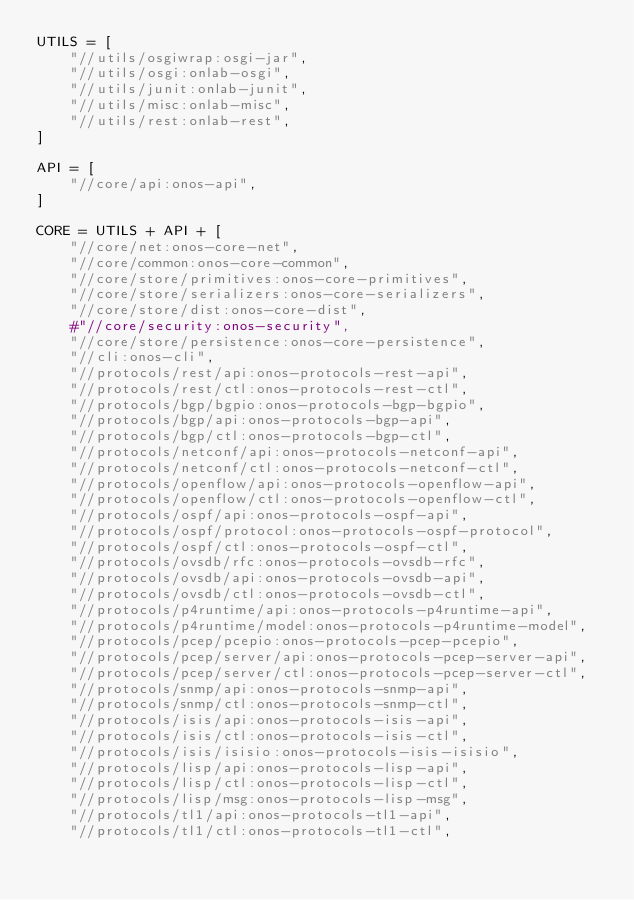Convert code to text. <code><loc_0><loc_0><loc_500><loc_500><_Python_>UTILS = [
    "//utils/osgiwrap:osgi-jar",
    "//utils/osgi:onlab-osgi",
    "//utils/junit:onlab-junit",
    "//utils/misc:onlab-misc",
    "//utils/rest:onlab-rest",
]

API = [
    "//core/api:onos-api",
]

CORE = UTILS + API + [
    "//core/net:onos-core-net",
    "//core/common:onos-core-common",
    "//core/store/primitives:onos-core-primitives",
    "//core/store/serializers:onos-core-serializers",
    "//core/store/dist:onos-core-dist",
    #"//core/security:onos-security",
    "//core/store/persistence:onos-core-persistence",
    "//cli:onos-cli",
    "//protocols/rest/api:onos-protocols-rest-api",
    "//protocols/rest/ctl:onos-protocols-rest-ctl",
    "//protocols/bgp/bgpio:onos-protocols-bgp-bgpio",
    "//protocols/bgp/api:onos-protocols-bgp-api",
    "//protocols/bgp/ctl:onos-protocols-bgp-ctl",
    "//protocols/netconf/api:onos-protocols-netconf-api",
    "//protocols/netconf/ctl:onos-protocols-netconf-ctl",
    "//protocols/openflow/api:onos-protocols-openflow-api",
    "//protocols/openflow/ctl:onos-protocols-openflow-ctl",
    "//protocols/ospf/api:onos-protocols-ospf-api",
    "//protocols/ospf/protocol:onos-protocols-ospf-protocol",
    "//protocols/ospf/ctl:onos-protocols-ospf-ctl",
    "//protocols/ovsdb/rfc:onos-protocols-ovsdb-rfc",
    "//protocols/ovsdb/api:onos-protocols-ovsdb-api",
    "//protocols/ovsdb/ctl:onos-protocols-ovsdb-ctl",
    "//protocols/p4runtime/api:onos-protocols-p4runtime-api",
    "//protocols/p4runtime/model:onos-protocols-p4runtime-model",
    "//protocols/pcep/pcepio:onos-protocols-pcep-pcepio",
    "//protocols/pcep/server/api:onos-protocols-pcep-server-api",
    "//protocols/pcep/server/ctl:onos-protocols-pcep-server-ctl",
    "//protocols/snmp/api:onos-protocols-snmp-api",
    "//protocols/snmp/ctl:onos-protocols-snmp-ctl",
    "//protocols/isis/api:onos-protocols-isis-api",
    "//protocols/isis/ctl:onos-protocols-isis-ctl",
    "//protocols/isis/isisio:onos-protocols-isis-isisio",
    "//protocols/lisp/api:onos-protocols-lisp-api",
    "//protocols/lisp/ctl:onos-protocols-lisp-ctl",
    "//protocols/lisp/msg:onos-protocols-lisp-msg",
    "//protocols/tl1/api:onos-protocols-tl1-api",
    "//protocols/tl1/ctl:onos-protocols-tl1-ctl",</code> 